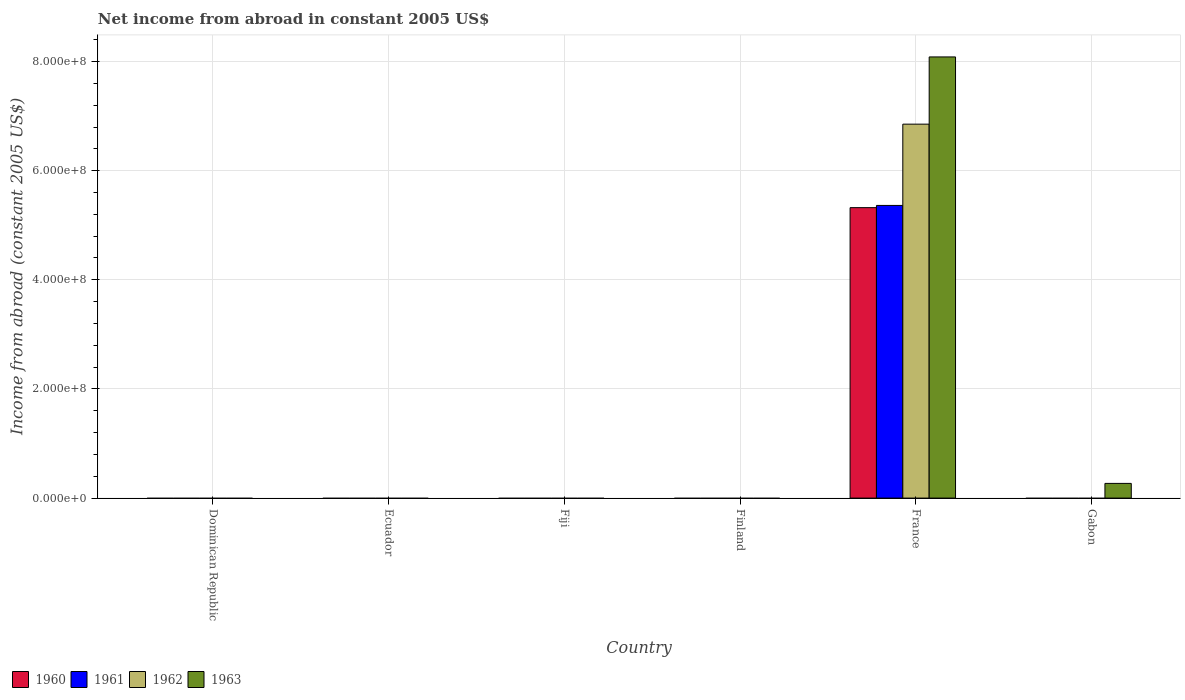How many different coloured bars are there?
Make the answer very short. 4. Are the number of bars on each tick of the X-axis equal?
Provide a short and direct response. No. How many bars are there on the 5th tick from the left?
Your answer should be very brief. 4. What is the label of the 2nd group of bars from the left?
Offer a terse response. Ecuador. In how many cases, is the number of bars for a given country not equal to the number of legend labels?
Provide a short and direct response. 5. What is the net income from abroad in 1963 in Finland?
Your response must be concise. 0. Across all countries, what is the maximum net income from abroad in 1962?
Provide a short and direct response. 6.85e+08. What is the total net income from abroad in 1962 in the graph?
Offer a very short reply. 6.85e+08. What is the average net income from abroad in 1961 per country?
Keep it short and to the point. 8.94e+07. What is the difference between the highest and the lowest net income from abroad in 1963?
Your answer should be compact. 8.08e+08. How many bars are there?
Give a very brief answer. 5. How many countries are there in the graph?
Provide a short and direct response. 6. Are the values on the major ticks of Y-axis written in scientific E-notation?
Offer a terse response. Yes. How many legend labels are there?
Your answer should be compact. 4. What is the title of the graph?
Your response must be concise. Net income from abroad in constant 2005 US$. Does "2003" appear as one of the legend labels in the graph?
Offer a very short reply. No. What is the label or title of the X-axis?
Offer a terse response. Country. What is the label or title of the Y-axis?
Your response must be concise. Income from abroad (constant 2005 US$). What is the Income from abroad (constant 2005 US$) of 1960 in Dominican Republic?
Your answer should be compact. 0. What is the Income from abroad (constant 2005 US$) in 1963 in Dominican Republic?
Keep it short and to the point. 0. What is the Income from abroad (constant 2005 US$) in 1963 in Ecuador?
Give a very brief answer. 0. What is the Income from abroad (constant 2005 US$) of 1960 in Finland?
Keep it short and to the point. 0. What is the Income from abroad (constant 2005 US$) of 1962 in Finland?
Your response must be concise. 0. What is the Income from abroad (constant 2005 US$) of 1960 in France?
Your answer should be very brief. 5.32e+08. What is the Income from abroad (constant 2005 US$) in 1961 in France?
Offer a very short reply. 5.36e+08. What is the Income from abroad (constant 2005 US$) in 1962 in France?
Make the answer very short. 6.85e+08. What is the Income from abroad (constant 2005 US$) in 1963 in France?
Offer a terse response. 8.08e+08. What is the Income from abroad (constant 2005 US$) of 1960 in Gabon?
Your answer should be compact. 0. What is the Income from abroad (constant 2005 US$) in 1962 in Gabon?
Offer a terse response. 0. What is the Income from abroad (constant 2005 US$) of 1963 in Gabon?
Give a very brief answer. 2.69e+07. Across all countries, what is the maximum Income from abroad (constant 2005 US$) in 1960?
Ensure brevity in your answer.  5.32e+08. Across all countries, what is the maximum Income from abroad (constant 2005 US$) of 1961?
Provide a succinct answer. 5.36e+08. Across all countries, what is the maximum Income from abroad (constant 2005 US$) in 1962?
Ensure brevity in your answer.  6.85e+08. Across all countries, what is the maximum Income from abroad (constant 2005 US$) in 1963?
Your answer should be very brief. 8.08e+08. Across all countries, what is the minimum Income from abroad (constant 2005 US$) of 1960?
Keep it short and to the point. 0. Across all countries, what is the minimum Income from abroad (constant 2005 US$) in 1961?
Offer a terse response. 0. Across all countries, what is the minimum Income from abroad (constant 2005 US$) of 1962?
Your response must be concise. 0. Across all countries, what is the minimum Income from abroad (constant 2005 US$) in 1963?
Provide a succinct answer. 0. What is the total Income from abroad (constant 2005 US$) of 1960 in the graph?
Your response must be concise. 5.32e+08. What is the total Income from abroad (constant 2005 US$) of 1961 in the graph?
Your response must be concise. 5.36e+08. What is the total Income from abroad (constant 2005 US$) in 1962 in the graph?
Ensure brevity in your answer.  6.85e+08. What is the total Income from abroad (constant 2005 US$) in 1963 in the graph?
Give a very brief answer. 8.35e+08. What is the difference between the Income from abroad (constant 2005 US$) of 1963 in France and that in Gabon?
Provide a succinct answer. 7.81e+08. What is the difference between the Income from abroad (constant 2005 US$) of 1960 in France and the Income from abroad (constant 2005 US$) of 1963 in Gabon?
Provide a succinct answer. 5.05e+08. What is the difference between the Income from abroad (constant 2005 US$) of 1961 in France and the Income from abroad (constant 2005 US$) of 1963 in Gabon?
Provide a short and direct response. 5.09e+08. What is the difference between the Income from abroad (constant 2005 US$) in 1962 in France and the Income from abroad (constant 2005 US$) in 1963 in Gabon?
Provide a short and direct response. 6.58e+08. What is the average Income from abroad (constant 2005 US$) in 1960 per country?
Give a very brief answer. 8.87e+07. What is the average Income from abroad (constant 2005 US$) in 1961 per country?
Provide a succinct answer. 8.94e+07. What is the average Income from abroad (constant 2005 US$) of 1962 per country?
Make the answer very short. 1.14e+08. What is the average Income from abroad (constant 2005 US$) of 1963 per country?
Your response must be concise. 1.39e+08. What is the difference between the Income from abroad (constant 2005 US$) in 1960 and Income from abroad (constant 2005 US$) in 1961 in France?
Provide a succinct answer. -4.05e+06. What is the difference between the Income from abroad (constant 2005 US$) in 1960 and Income from abroad (constant 2005 US$) in 1962 in France?
Ensure brevity in your answer.  -1.53e+08. What is the difference between the Income from abroad (constant 2005 US$) of 1960 and Income from abroad (constant 2005 US$) of 1963 in France?
Give a very brief answer. -2.76e+08. What is the difference between the Income from abroad (constant 2005 US$) in 1961 and Income from abroad (constant 2005 US$) in 1962 in France?
Your answer should be very brief. -1.49e+08. What is the difference between the Income from abroad (constant 2005 US$) of 1961 and Income from abroad (constant 2005 US$) of 1963 in France?
Keep it short and to the point. -2.72e+08. What is the difference between the Income from abroad (constant 2005 US$) of 1962 and Income from abroad (constant 2005 US$) of 1963 in France?
Ensure brevity in your answer.  -1.23e+08. What is the ratio of the Income from abroad (constant 2005 US$) of 1963 in France to that in Gabon?
Provide a short and direct response. 30.04. What is the difference between the highest and the lowest Income from abroad (constant 2005 US$) in 1960?
Provide a succinct answer. 5.32e+08. What is the difference between the highest and the lowest Income from abroad (constant 2005 US$) of 1961?
Provide a short and direct response. 5.36e+08. What is the difference between the highest and the lowest Income from abroad (constant 2005 US$) in 1962?
Offer a terse response. 6.85e+08. What is the difference between the highest and the lowest Income from abroad (constant 2005 US$) of 1963?
Keep it short and to the point. 8.08e+08. 